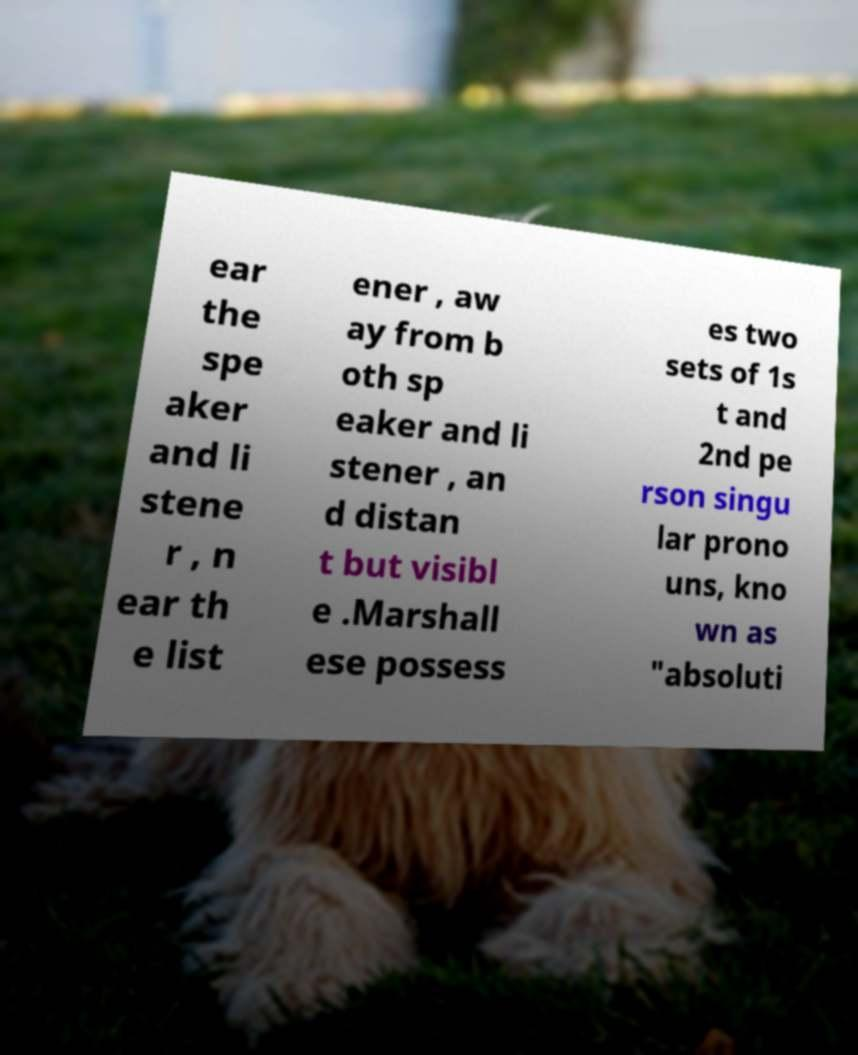What messages or text are displayed in this image? I need them in a readable, typed format. ear the spe aker and li stene r , n ear th e list ener , aw ay from b oth sp eaker and li stener , an d distan t but visibl e .Marshall ese possess es two sets of 1s t and 2nd pe rson singu lar prono uns, kno wn as "absoluti 